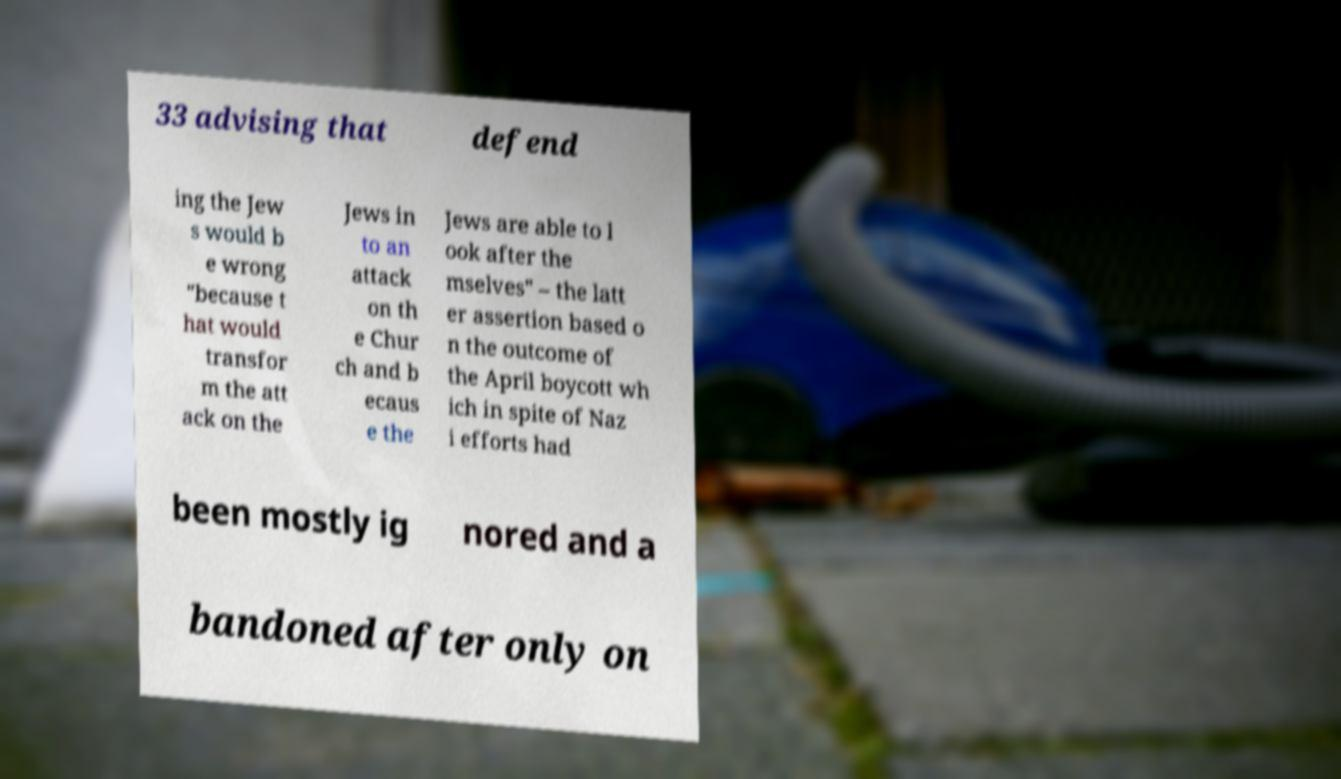I need the written content from this picture converted into text. Can you do that? 33 advising that defend ing the Jew s would b e wrong "because t hat would transfor m the att ack on the Jews in to an attack on th e Chur ch and b ecaus e the Jews are able to l ook after the mselves" – the latt er assertion based o n the outcome of the April boycott wh ich in spite of Naz i efforts had been mostly ig nored and a bandoned after only on 